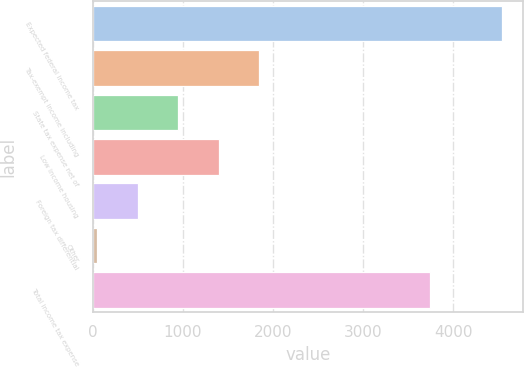<chart> <loc_0><loc_0><loc_500><loc_500><bar_chart><fcel>Expected federal income tax<fcel>Tax-exempt income including<fcel>State tax expense net of<fcel>Low income housing<fcel>Foreign tax differential<fcel>Other<fcel>Total income tax expense<nl><fcel>4547<fcel>1848.8<fcel>949.4<fcel>1399.1<fcel>499.7<fcel>50<fcel>3742<nl></chart> 